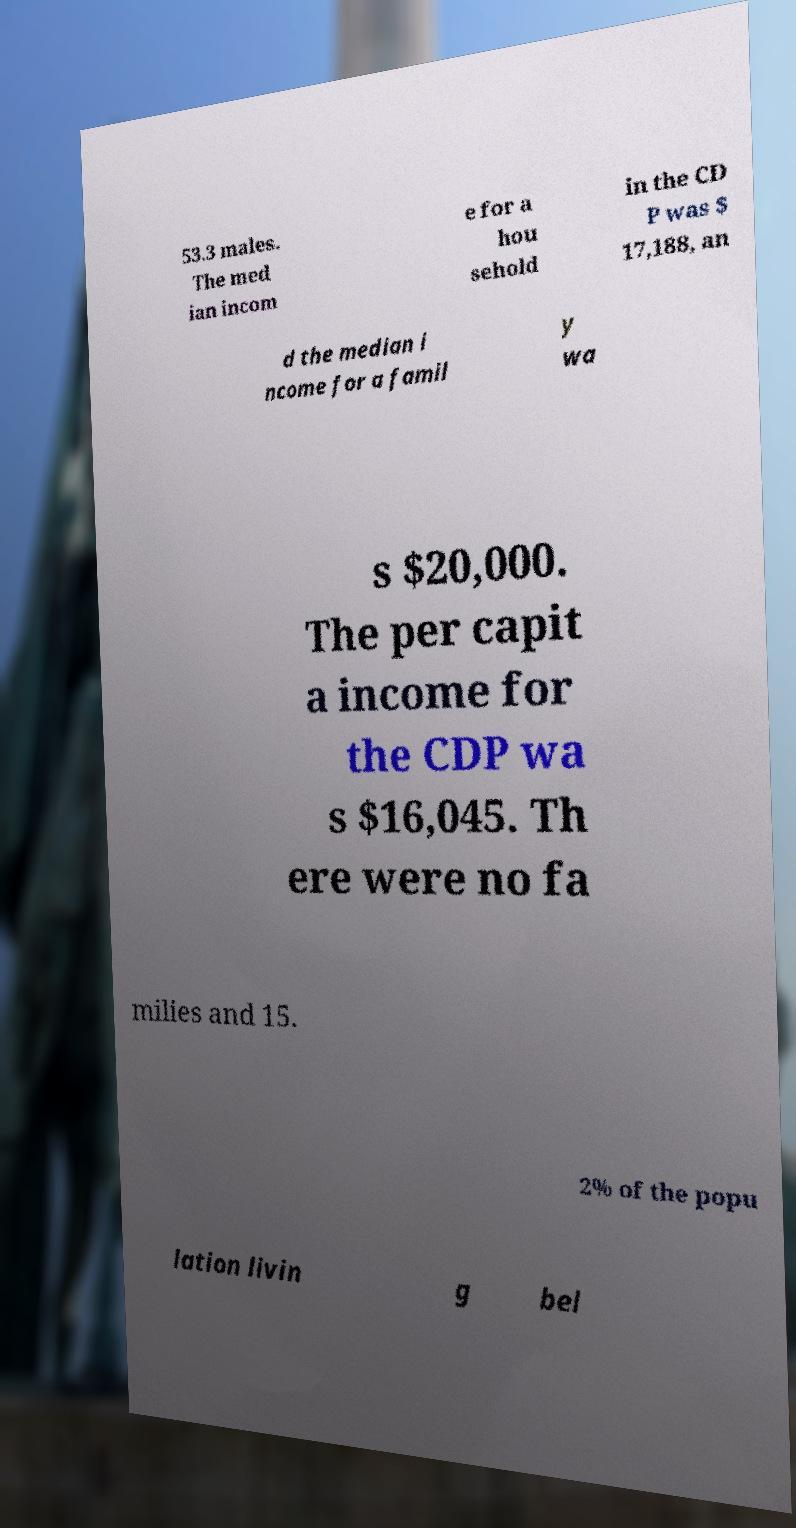I need the written content from this picture converted into text. Can you do that? 53.3 males. The med ian incom e for a hou sehold in the CD P was $ 17,188, an d the median i ncome for a famil y wa s $20,000. The per capit a income for the CDP wa s $16,045. Th ere were no fa milies and 15. 2% of the popu lation livin g bel 